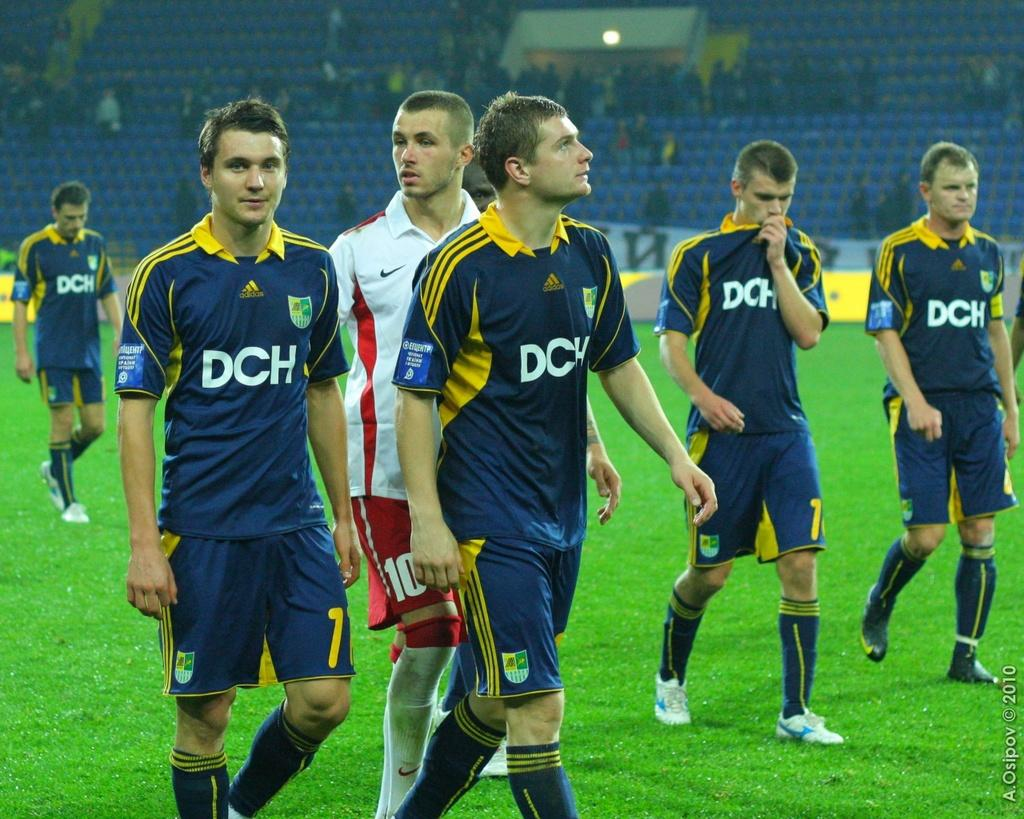<image>
Relay a brief, clear account of the picture shown. Several soccer players are wearing blue jerseys with the letters DCH printed on the chest. 